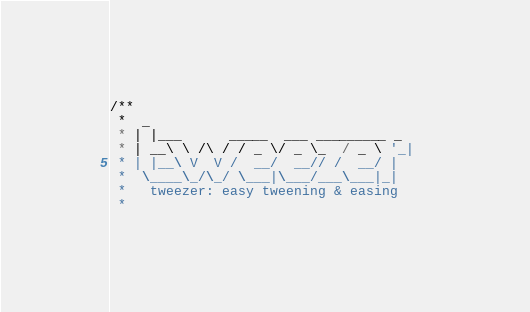<code> <loc_0><loc_0><loc_500><loc_500><_Haxe_>/**
 *  _                       
 * | |___      _____  ___ _________ _
 * | __\ \ /\ / / _ \/ _ \_  / _ \ '_|
 * | |__\ V  V /  __/  __// /  __/ |    
 *  \____\_/\_/ \___|\___/___\___|_|   
 *   tweezer: easy tweening & easing
 *</code> 